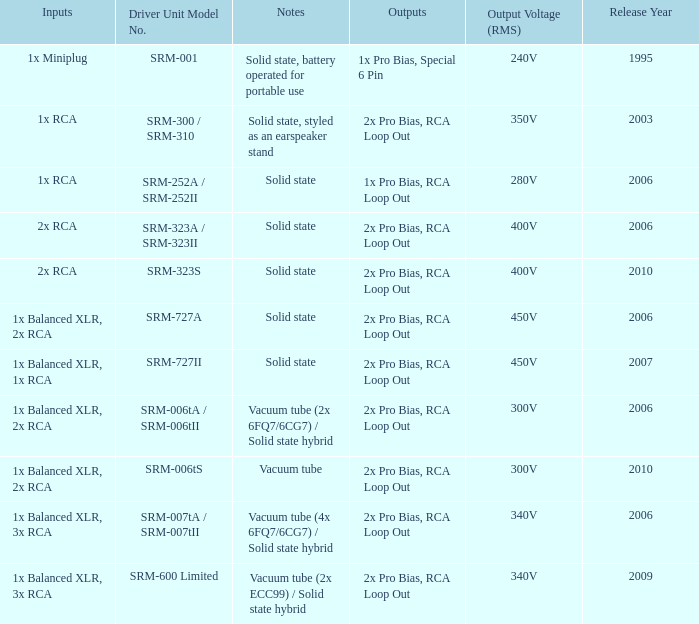How many solid-state, battery-operated outputs for portable use are mentioned in the notes? 1.0. 